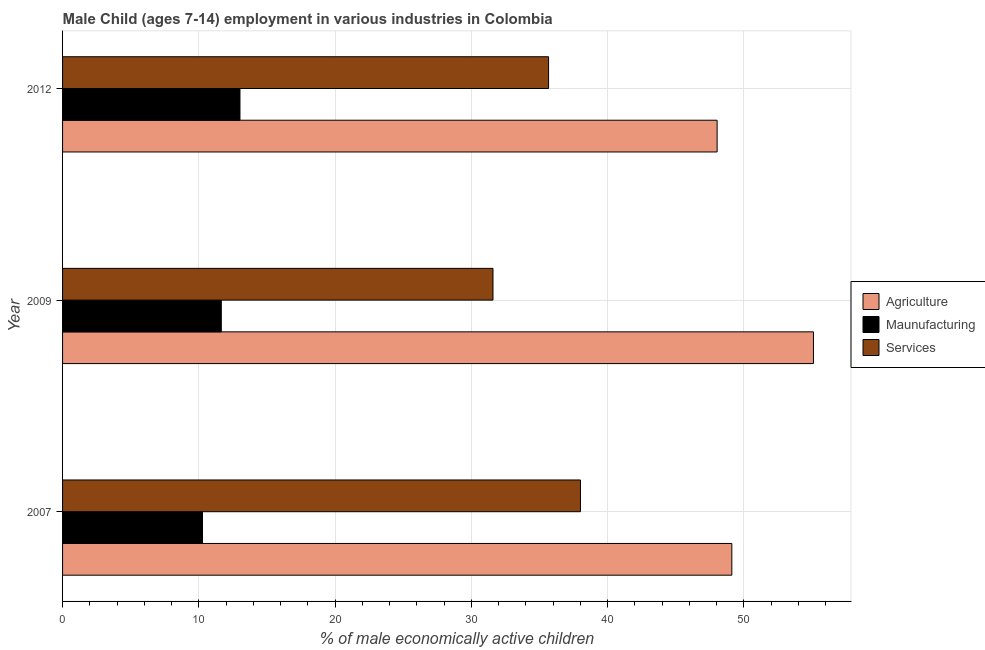How many different coloured bars are there?
Provide a succinct answer. 3. How many groups of bars are there?
Provide a short and direct response. 3. Are the number of bars per tick equal to the number of legend labels?
Offer a very short reply. Yes. Are the number of bars on each tick of the Y-axis equal?
Your answer should be very brief. Yes. What is the label of the 1st group of bars from the top?
Your answer should be compact. 2012. In how many cases, is the number of bars for a given year not equal to the number of legend labels?
Keep it short and to the point. 0. What is the percentage of economically active children in services in 2009?
Offer a terse response. 31.59. Across all years, what is the maximum percentage of economically active children in manufacturing?
Your answer should be compact. 13.02. Across all years, what is the minimum percentage of economically active children in manufacturing?
Make the answer very short. 10.27. In which year was the percentage of economically active children in agriculture minimum?
Keep it short and to the point. 2012. What is the total percentage of economically active children in manufacturing in the graph?
Offer a terse response. 34.94. What is the difference between the percentage of economically active children in manufacturing in 2009 and that in 2012?
Give a very brief answer. -1.37. What is the difference between the percentage of economically active children in manufacturing in 2007 and the percentage of economically active children in services in 2009?
Your answer should be compact. -21.32. What is the average percentage of economically active children in services per year?
Your answer should be very brief. 35.09. In the year 2012, what is the difference between the percentage of economically active children in services and percentage of economically active children in manufacturing?
Your answer should be very brief. 22.65. In how many years, is the percentage of economically active children in agriculture greater than 10 %?
Provide a short and direct response. 3. What is the ratio of the percentage of economically active children in services in 2007 to that in 2009?
Ensure brevity in your answer.  1.2. What is the difference between the highest and the second highest percentage of economically active children in agriculture?
Make the answer very short. 5.99. What is the difference between the highest and the lowest percentage of economically active children in manufacturing?
Make the answer very short. 2.75. In how many years, is the percentage of economically active children in manufacturing greater than the average percentage of economically active children in manufacturing taken over all years?
Offer a terse response. 2. Is the sum of the percentage of economically active children in manufacturing in 2009 and 2012 greater than the maximum percentage of economically active children in agriculture across all years?
Keep it short and to the point. No. What does the 2nd bar from the top in 2009 represents?
Your answer should be very brief. Maunufacturing. What does the 3rd bar from the bottom in 2009 represents?
Offer a very short reply. Services. How many bars are there?
Ensure brevity in your answer.  9. How many years are there in the graph?
Keep it short and to the point. 3. Does the graph contain grids?
Offer a very short reply. Yes. Where does the legend appear in the graph?
Provide a short and direct response. Center right. What is the title of the graph?
Offer a very short reply. Male Child (ages 7-14) employment in various industries in Colombia. What is the label or title of the X-axis?
Your response must be concise. % of male economically active children. What is the % of male economically active children of Agriculture in 2007?
Offer a very short reply. 49.12. What is the % of male economically active children of Maunufacturing in 2007?
Your answer should be compact. 10.27. What is the % of male economically active children of Services in 2007?
Provide a succinct answer. 38.01. What is the % of male economically active children in Agriculture in 2009?
Offer a very short reply. 55.11. What is the % of male economically active children of Maunufacturing in 2009?
Your answer should be very brief. 11.65. What is the % of male economically active children in Services in 2009?
Offer a very short reply. 31.59. What is the % of male economically active children of Agriculture in 2012?
Offer a very short reply. 48.04. What is the % of male economically active children in Maunufacturing in 2012?
Your answer should be very brief. 13.02. What is the % of male economically active children of Services in 2012?
Keep it short and to the point. 35.67. Across all years, what is the maximum % of male economically active children of Agriculture?
Provide a succinct answer. 55.11. Across all years, what is the maximum % of male economically active children in Maunufacturing?
Make the answer very short. 13.02. Across all years, what is the maximum % of male economically active children in Services?
Give a very brief answer. 38.01. Across all years, what is the minimum % of male economically active children of Agriculture?
Make the answer very short. 48.04. Across all years, what is the minimum % of male economically active children of Maunufacturing?
Give a very brief answer. 10.27. Across all years, what is the minimum % of male economically active children in Services?
Provide a short and direct response. 31.59. What is the total % of male economically active children in Agriculture in the graph?
Provide a short and direct response. 152.27. What is the total % of male economically active children of Maunufacturing in the graph?
Your answer should be very brief. 34.94. What is the total % of male economically active children of Services in the graph?
Offer a terse response. 105.27. What is the difference between the % of male economically active children of Agriculture in 2007 and that in 2009?
Your answer should be very brief. -5.99. What is the difference between the % of male economically active children in Maunufacturing in 2007 and that in 2009?
Your response must be concise. -1.38. What is the difference between the % of male economically active children in Services in 2007 and that in 2009?
Provide a short and direct response. 6.42. What is the difference between the % of male economically active children in Maunufacturing in 2007 and that in 2012?
Ensure brevity in your answer.  -2.75. What is the difference between the % of male economically active children in Services in 2007 and that in 2012?
Offer a very short reply. 2.34. What is the difference between the % of male economically active children in Agriculture in 2009 and that in 2012?
Your answer should be compact. 7.07. What is the difference between the % of male economically active children in Maunufacturing in 2009 and that in 2012?
Give a very brief answer. -1.37. What is the difference between the % of male economically active children of Services in 2009 and that in 2012?
Keep it short and to the point. -4.08. What is the difference between the % of male economically active children of Agriculture in 2007 and the % of male economically active children of Maunufacturing in 2009?
Ensure brevity in your answer.  37.47. What is the difference between the % of male economically active children in Agriculture in 2007 and the % of male economically active children in Services in 2009?
Your answer should be very brief. 17.53. What is the difference between the % of male economically active children of Maunufacturing in 2007 and the % of male economically active children of Services in 2009?
Ensure brevity in your answer.  -21.32. What is the difference between the % of male economically active children of Agriculture in 2007 and the % of male economically active children of Maunufacturing in 2012?
Your response must be concise. 36.1. What is the difference between the % of male economically active children in Agriculture in 2007 and the % of male economically active children in Services in 2012?
Give a very brief answer. 13.45. What is the difference between the % of male economically active children in Maunufacturing in 2007 and the % of male economically active children in Services in 2012?
Your response must be concise. -25.4. What is the difference between the % of male economically active children of Agriculture in 2009 and the % of male economically active children of Maunufacturing in 2012?
Provide a short and direct response. 42.09. What is the difference between the % of male economically active children of Agriculture in 2009 and the % of male economically active children of Services in 2012?
Provide a succinct answer. 19.44. What is the difference between the % of male economically active children in Maunufacturing in 2009 and the % of male economically active children in Services in 2012?
Make the answer very short. -24.02. What is the average % of male economically active children of Agriculture per year?
Provide a succinct answer. 50.76. What is the average % of male economically active children in Maunufacturing per year?
Keep it short and to the point. 11.65. What is the average % of male economically active children in Services per year?
Offer a terse response. 35.09. In the year 2007, what is the difference between the % of male economically active children in Agriculture and % of male economically active children in Maunufacturing?
Provide a short and direct response. 38.85. In the year 2007, what is the difference between the % of male economically active children of Agriculture and % of male economically active children of Services?
Offer a very short reply. 11.11. In the year 2007, what is the difference between the % of male economically active children in Maunufacturing and % of male economically active children in Services?
Provide a short and direct response. -27.74. In the year 2009, what is the difference between the % of male economically active children in Agriculture and % of male economically active children in Maunufacturing?
Provide a short and direct response. 43.46. In the year 2009, what is the difference between the % of male economically active children of Agriculture and % of male economically active children of Services?
Provide a short and direct response. 23.52. In the year 2009, what is the difference between the % of male economically active children of Maunufacturing and % of male economically active children of Services?
Provide a succinct answer. -19.94. In the year 2012, what is the difference between the % of male economically active children in Agriculture and % of male economically active children in Maunufacturing?
Make the answer very short. 35.02. In the year 2012, what is the difference between the % of male economically active children of Agriculture and % of male economically active children of Services?
Keep it short and to the point. 12.37. In the year 2012, what is the difference between the % of male economically active children in Maunufacturing and % of male economically active children in Services?
Make the answer very short. -22.65. What is the ratio of the % of male economically active children in Agriculture in 2007 to that in 2009?
Provide a succinct answer. 0.89. What is the ratio of the % of male economically active children in Maunufacturing in 2007 to that in 2009?
Keep it short and to the point. 0.88. What is the ratio of the % of male economically active children of Services in 2007 to that in 2009?
Provide a short and direct response. 1.2. What is the ratio of the % of male economically active children of Agriculture in 2007 to that in 2012?
Make the answer very short. 1.02. What is the ratio of the % of male economically active children of Maunufacturing in 2007 to that in 2012?
Offer a very short reply. 0.79. What is the ratio of the % of male economically active children of Services in 2007 to that in 2012?
Offer a terse response. 1.07. What is the ratio of the % of male economically active children in Agriculture in 2009 to that in 2012?
Make the answer very short. 1.15. What is the ratio of the % of male economically active children in Maunufacturing in 2009 to that in 2012?
Offer a very short reply. 0.89. What is the ratio of the % of male economically active children in Services in 2009 to that in 2012?
Ensure brevity in your answer.  0.89. What is the difference between the highest and the second highest % of male economically active children of Agriculture?
Make the answer very short. 5.99. What is the difference between the highest and the second highest % of male economically active children in Maunufacturing?
Keep it short and to the point. 1.37. What is the difference between the highest and the second highest % of male economically active children of Services?
Offer a very short reply. 2.34. What is the difference between the highest and the lowest % of male economically active children in Agriculture?
Give a very brief answer. 7.07. What is the difference between the highest and the lowest % of male economically active children of Maunufacturing?
Your answer should be compact. 2.75. What is the difference between the highest and the lowest % of male economically active children in Services?
Your response must be concise. 6.42. 